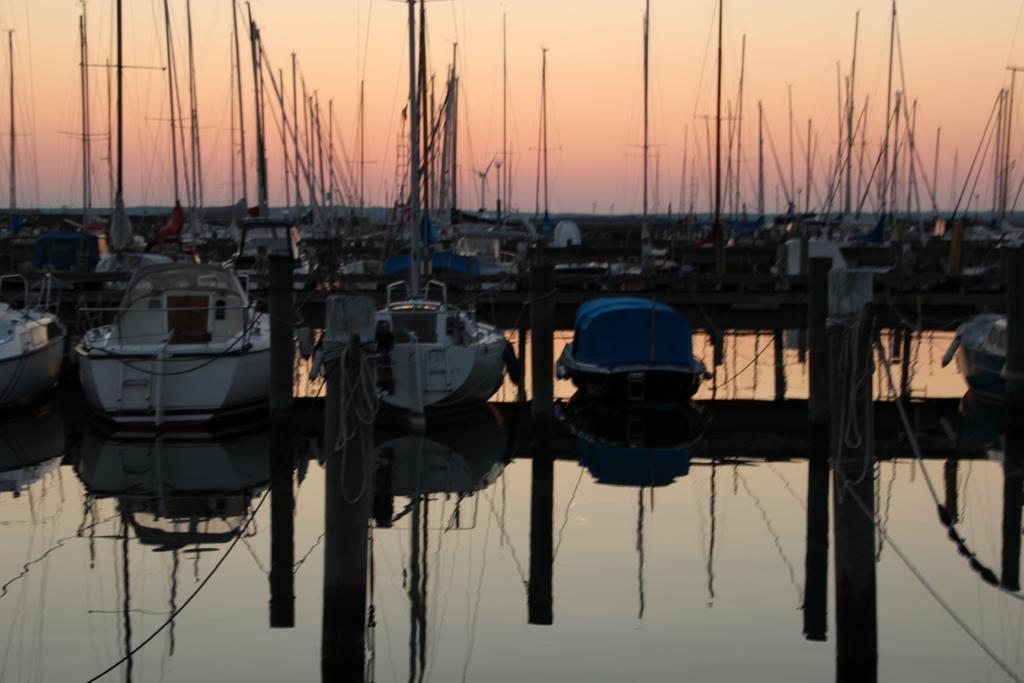Please provide a concise description of this image. At the bottom of the image there is water. On the water there are many boats with poles and ropes. And also there are wooden poles in the water. Behind the boats there is sky in the background. 